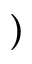Convert formula to latex. <formula><loc_0><loc_0><loc_500><loc_500>)</formula> 